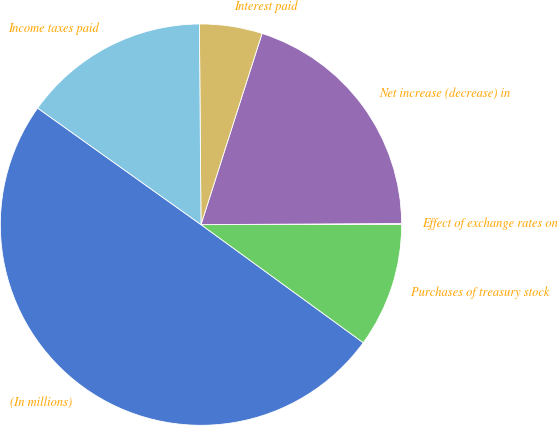Convert chart to OTSL. <chart><loc_0><loc_0><loc_500><loc_500><pie_chart><fcel>(In millions)<fcel>Purchases of treasury stock<fcel>Effect of exchange rates on<fcel>Net increase (decrease) in<fcel>Interest paid<fcel>Income taxes paid<nl><fcel>49.85%<fcel>10.03%<fcel>0.07%<fcel>19.99%<fcel>5.05%<fcel>15.01%<nl></chart> 